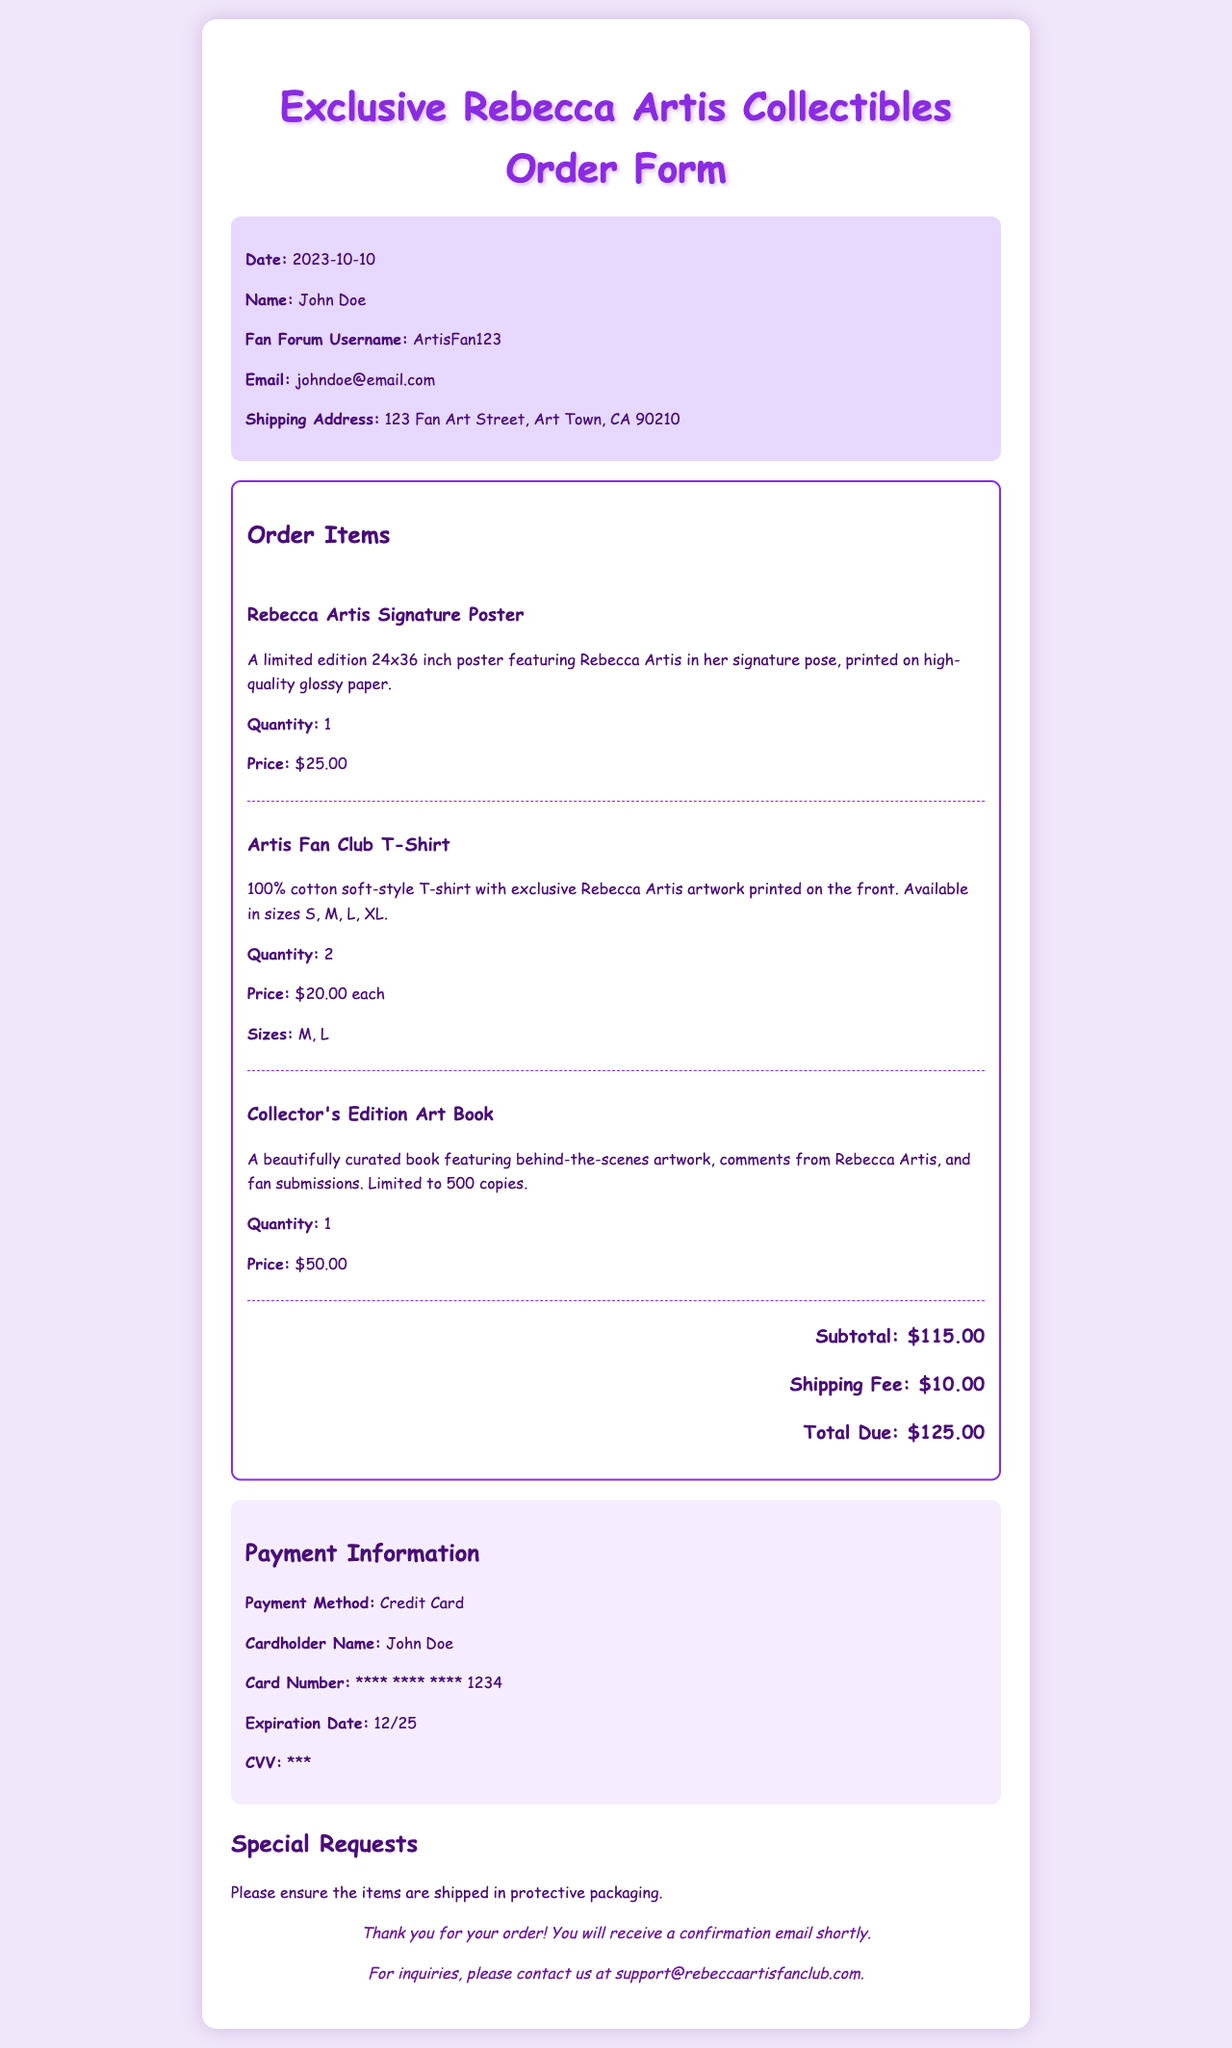What is the date of the order? The date of the order is specified in the order info section, which is 2023-10-10.
Answer: 2023-10-10 Who is the cardholder? The cardholder's name is mentioned in the payment information section, which is John Doe.
Answer: John Doe How many Artis Fan Club T-Shirts were ordered? The quantity of Artis Fan Club T-Shirts can be found in the order items section, which states 2.
Answer: 2 What is the total due amount? The total due amount is indicated at the bottom of the order items section, which is $125.00.
Answer: $125.00 What payment method was used? The payment method is outlined in the payment information section, which is Credit Card.
Answer: Credit Card What special request was made regarding the order? The special request details are provided in the special requests section, which asks for protective packaging.
Answer: protective packaging What is the price of the Collector's Edition Art Book? The price for the Collector's Edition Art Book is mentioned in the order items section as $50.00.
Answer: $50.00 What sizes were requested for the T-Shirts? The requested sizes for the T-Shirts are specified in the order items section, which are M and L.
Answer: M, L How many total items are ordered? The total number of items can be calculated by adding the quantities of all ordered items: 1 poster + 2 T-shirts + 1 art book = 4.
Answer: 4 